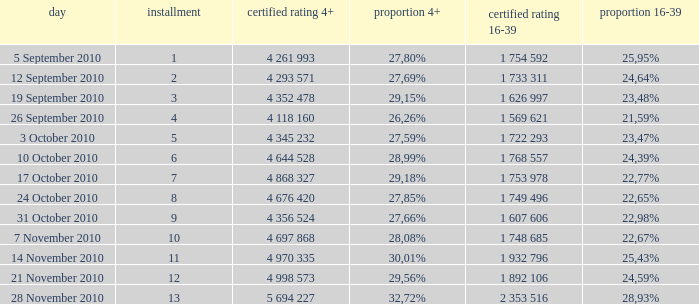What is the 16-39 share of the episode with a 4+ share of 30,01%? 25,43%. 